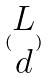<formula> <loc_0><loc_0><loc_500><loc_500>( \begin{matrix} L \\ d \end{matrix} )</formula> 